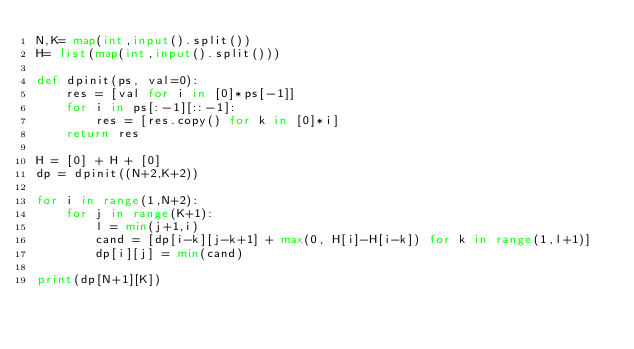<code> <loc_0><loc_0><loc_500><loc_500><_Python_>N,K= map(int,input().split())
H= list(map(int,input().split()))

def dpinit(ps, val=0):
    res = [val for i in [0]*ps[-1]]
    for i in ps[:-1][::-1]:
        res = [res.copy() for k in [0]*i]
    return res

H = [0] + H + [0]
dp = dpinit((N+2,K+2))

for i in range(1,N+2):
    for j in range(K+1):
        l = min(j+1,i)
        cand = [dp[i-k][j-k+1] + max(0, H[i]-H[i-k]) for k in range(1,l+1)]
        dp[i][j] = min(cand)

print(dp[N+1][K])

</code> 